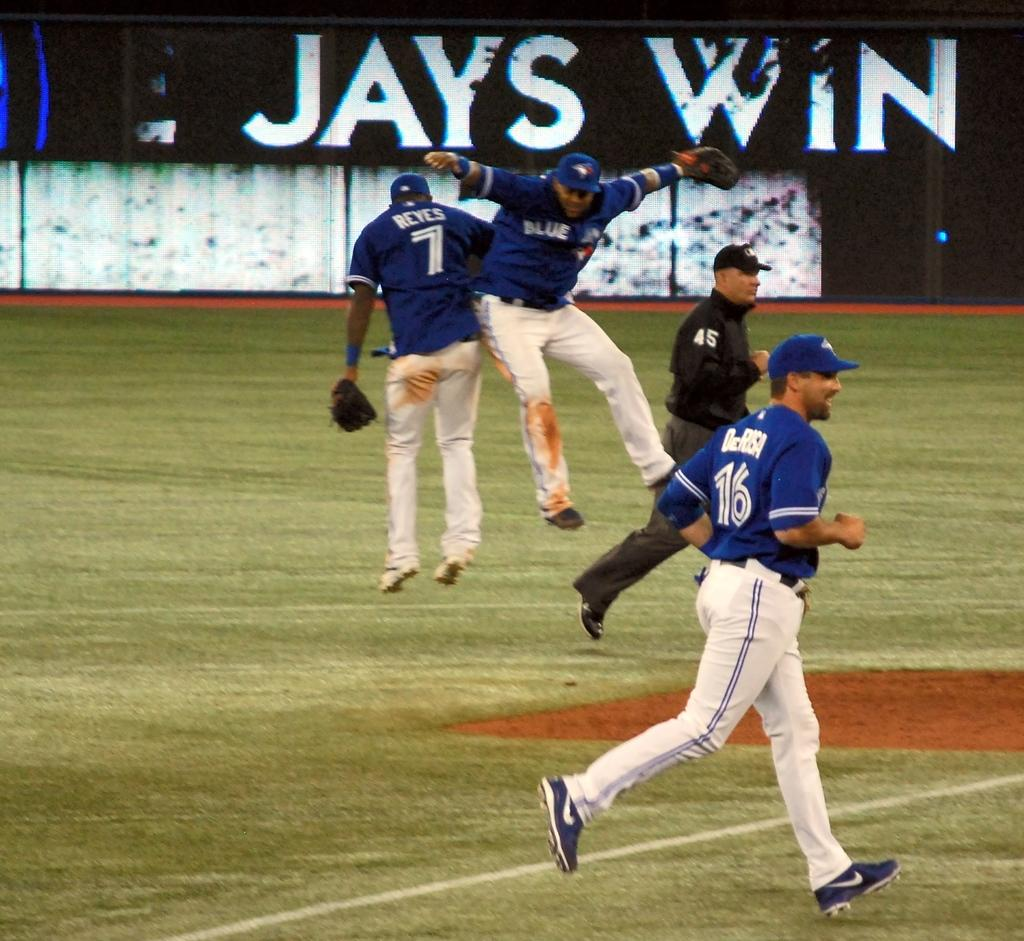What sport are the players in the image participating in? The players in the image are participating in baseball. What action are the baseball players performing in the image? The baseball players are running on the ground. What type of machine is being used by the son in the image? There is no son or machine present in the image; it features baseball players running on the ground. 